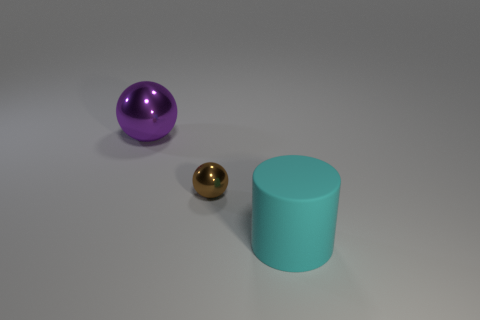Are there fewer purple matte cubes than small objects?
Make the answer very short. Yes. What shape is the metal object in front of the large thing left of the cyan object?
Your answer should be compact. Sphere. Are there any tiny spheres in front of the big cyan matte object?
Offer a very short reply. No. What is the color of the thing that is the same size as the cylinder?
Your response must be concise. Purple. How many cyan cylinders have the same material as the big cyan object?
Make the answer very short. 0. What number of other things are there of the same size as the purple shiny sphere?
Ensure brevity in your answer.  1. Is there a purple shiny ball of the same size as the brown sphere?
Your response must be concise. No. There is a shiny object that is on the right side of the big sphere; is it the same color as the cylinder?
Your answer should be very brief. No. How many things are small blue metal blocks or purple objects?
Provide a succinct answer. 1. Does the thing right of the brown shiny sphere have the same size as the purple shiny ball?
Provide a short and direct response. Yes. 